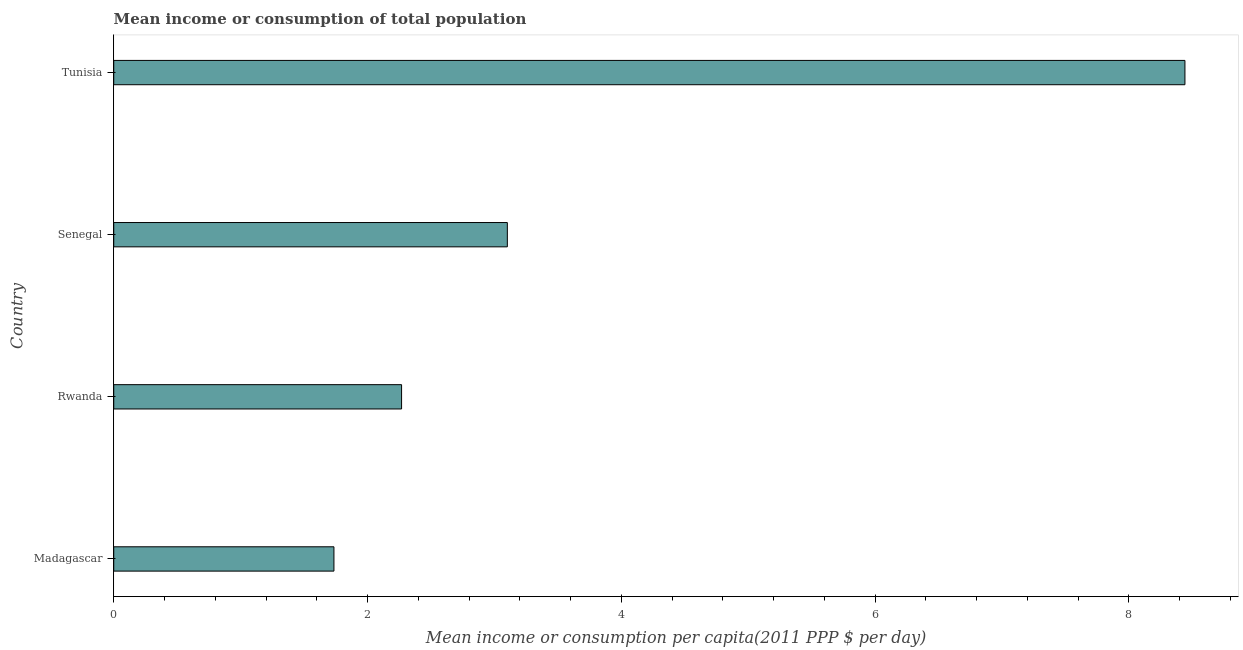Does the graph contain grids?
Provide a short and direct response. No. What is the title of the graph?
Ensure brevity in your answer.  Mean income or consumption of total population. What is the label or title of the X-axis?
Offer a very short reply. Mean income or consumption per capita(2011 PPP $ per day). What is the mean income or consumption in Senegal?
Ensure brevity in your answer.  3.1. Across all countries, what is the maximum mean income or consumption?
Offer a terse response. 8.44. Across all countries, what is the minimum mean income or consumption?
Offer a very short reply. 1.74. In which country was the mean income or consumption maximum?
Provide a succinct answer. Tunisia. In which country was the mean income or consumption minimum?
Your answer should be compact. Madagascar. What is the sum of the mean income or consumption?
Your response must be concise. 15.55. What is the difference between the mean income or consumption in Madagascar and Tunisia?
Offer a terse response. -6.71. What is the average mean income or consumption per country?
Offer a terse response. 3.89. What is the median mean income or consumption?
Your response must be concise. 2.69. In how many countries, is the mean income or consumption greater than 2.4 $?
Your answer should be very brief. 2. What is the ratio of the mean income or consumption in Madagascar to that in Rwanda?
Your answer should be very brief. 0.77. Is the difference between the mean income or consumption in Madagascar and Tunisia greater than the difference between any two countries?
Make the answer very short. Yes. What is the difference between the highest and the second highest mean income or consumption?
Offer a terse response. 5.34. Is the sum of the mean income or consumption in Madagascar and Rwanda greater than the maximum mean income or consumption across all countries?
Offer a very short reply. No. What is the difference between the highest and the lowest mean income or consumption?
Keep it short and to the point. 6.71. In how many countries, is the mean income or consumption greater than the average mean income or consumption taken over all countries?
Ensure brevity in your answer.  1. Are all the bars in the graph horizontal?
Provide a short and direct response. Yes. What is the difference between two consecutive major ticks on the X-axis?
Give a very brief answer. 2. What is the Mean income or consumption per capita(2011 PPP $ per day) in Madagascar?
Provide a succinct answer. 1.74. What is the Mean income or consumption per capita(2011 PPP $ per day) in Rwanda?
Ensure brevity in your answer.  2.27. What is the Mean income or consumption per capita(2011 PPP $ per day) in Senegal?
Make the answer very short. 3.1. What is the Mean income or consumption per capita(2011 PPP $ per day) of Tunisia?
Make the answer very short. 8.44. What is the difference between the Mean income or consumption per capita(2011 PPP $ per day) in Madagascar and Rwanda?
Provide a succinct answer. -0.53. What is the difference between the Mean income or consumption per capita(2011 PPP $ per day) in Madagascar and Senegal?
Offer a terse response. -1.37. What is the difference between the Mean income or consumption per capita(2011 PPP $ per day) in Madagascar and Tunisia?
Your answer should be very brief. -6.71. What is the difference between the Mean income or consumption per capita(2011 PPP $ per day) in Rwanda and Senegal?
Make the answer very short. -0.83. What is the difference between the Mean income or consumption per capita(2011 PPP $ per day) in Rwanda and Tunisia?
Give a very brief answer. -6.17. What is the difference between the Mean income or consumption per capita(2011 PPP $ per day) in Senegal and Tunisia?
Provide a short and direct response. -5.34. What is the ratio of the Mean income or consumption per capita(2011 PPP $ per day) in Madagascar to that in Rwanda?
Your answer should be compact. 0.77. What is the ratio of the Mean income or consumption per capita(2011 PPP $ per day) in Madagascar to that in Senegal?
Your answer should be very brief. 0.56. What is the ratio of the Mean income or consumption per capita(2011 PPP $ per day) in Madagascar to that in Tunisia?
Offer a terse response. 0.21. What is the ratio of the Mean income or consumption per capita(2011 PPP $ per day) in Rwanda to that in Senegal?
Offer a very short reply. 0.73. What is the ratio of the Mean income or consumption per capita(2011 PPP $ per day) in Rwanda to that in Tunisia?
Your response must be concise. 0.27. What is the ratio of the Mean income or consumption per capita(2011 PPP $ per day) in Senegal to that in Tunisia?
Keep it short and to the point. 0.37. 